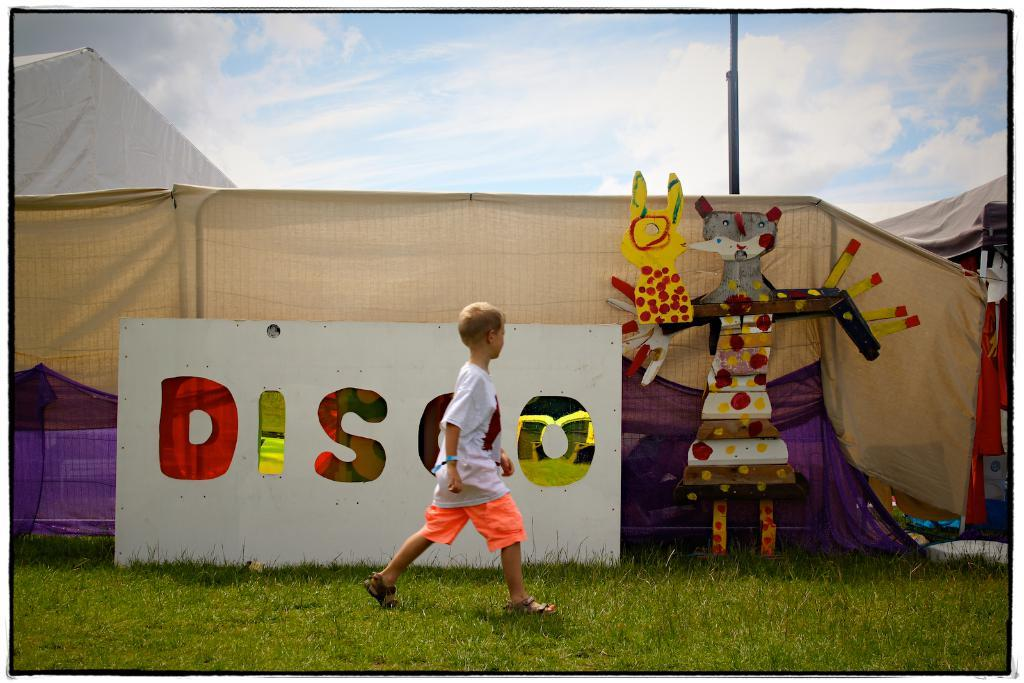Provide a one-sentence caption for the provided image. A boy is walking past a sign that says Disco. 